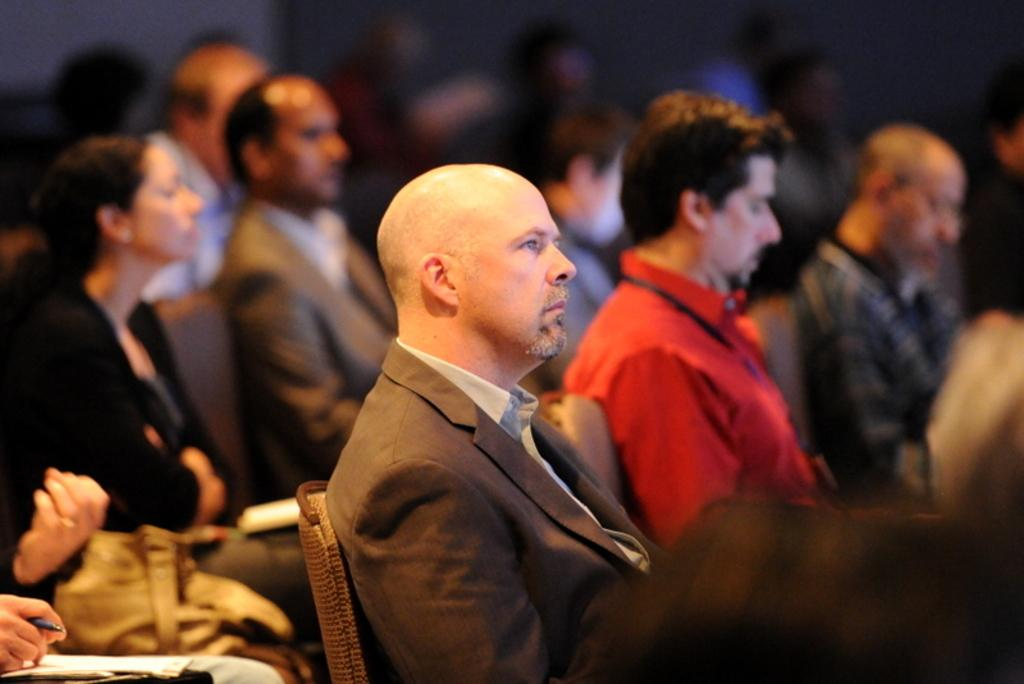What are the people in the image doing? The people in the image are sitting. Can you describe the activity of the person in the bottom left corner of the image? The person in the bottom left corner of the image is holding a pen and paper. What can be observed about the background of the image? The background of the image is blurred. How many cacti are visible in the image? There are no cacti present in the image. What type of grip does the person in the image have on the pen? The image does not provide enough detail to determine the type of grip the person has on the pen. 